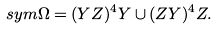Convert formula to latex. <formula><loc_0><loc_0><loc_500><loc_500>\ s y m \Omega = ( Y Z ) ^ { 4 } Y \cup ( Z Y ) ^ { 4 } Z .</formula> 